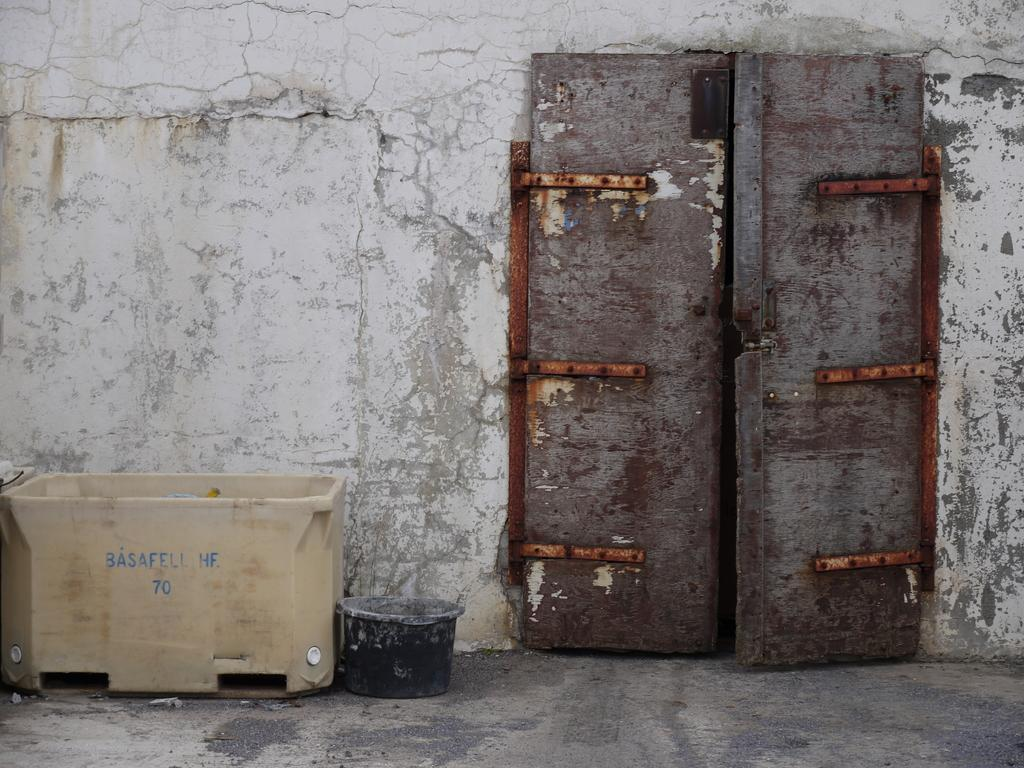What type of door is visible in the image? There is a closed wooden door in the image. Where is the door located? The door is on a wall. What objects are beside the door? There are two plastic containers beside the door. Where is the nearest drain to the door in the image? There is no drain visible in the image, so it cannot be determined from the image. 